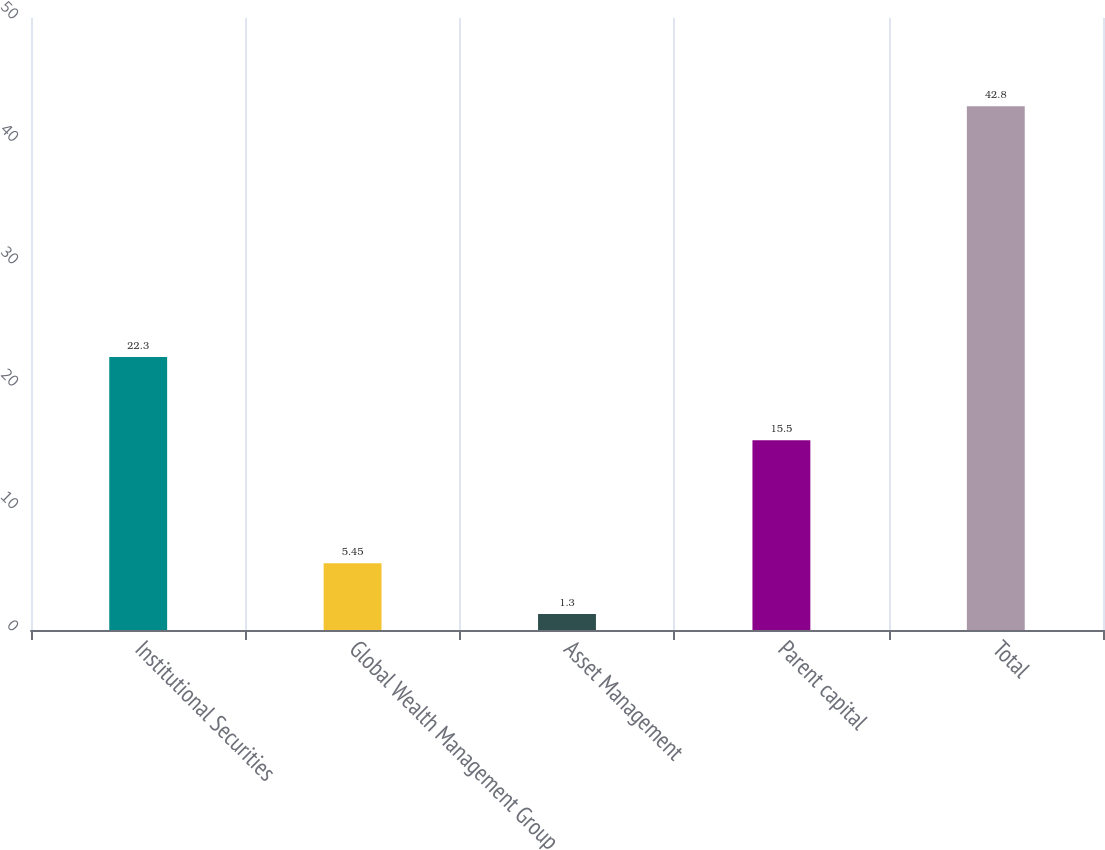Convert chart to OTSL. <chart><loc_0><loc_0><loc_500><loc_500><bar_chart><fcel>Institutional Securities<fcel>Global Wealth Management Group<fcel>Asset Management<fcel>Parent capital<fcel>Total<nl><fcel>22.3<fcel>5.45<fcel>1.3<fcel>15.5<fcel>42.8<nl></chart> 